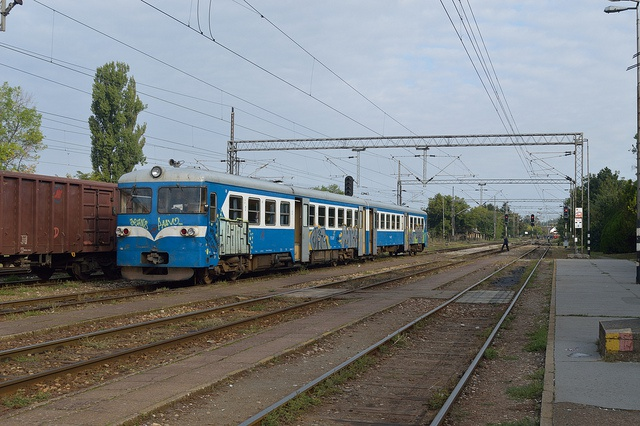Describe the objects in this image and their specific colors. I can see train in lightblue, black, blue, gray, and darkgray tones, train in lightblue, maroon, black, and brown tones, traffic light in lightblue, black, gray, and darkgray tones, people in lightblue, black, and gray tones, and traffic light in lightblue, black, and purple tones in this image. 